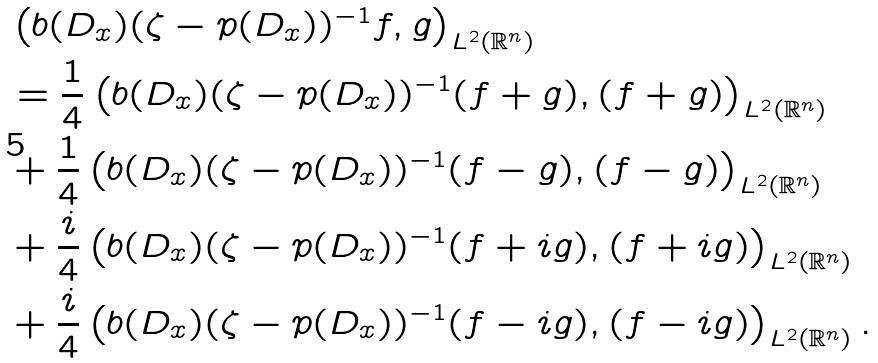<formula> <loc_0><loc_0><loc_500><loc_500>& \left ( b ( D _ { x } ) ( \zeta - p ( D _ { x } ) ) ^ { - 1 } f , g \right ) _ { L ^ { 2 } ( \mathbb { R } ^ { n } ) } \\ & = \frac { 1 } { 4 } \left ( b ( D _ { x } ) ( \zeta - p ( D _ { x } ) ) ^ { - 1 } ( f + g ) , ( f + g ) \right ) _ { L ^ { 2 } ( \mathbb { R } ^ { n } ) } \\ & + \frac { 1 } { 4 } \left ( b ( D _ { x } ) ( \zeta - p ( D _ { x } ) ) ^ { - 1 } ( f - g ) , ( f - g ) \right ) _ { L ^ { 2 } ( \mathbb { R } ^ { n } ) } \\ & + \frac { i } { 4 } \left ( b ( D _ { x } ) ( \zeta - p ( D _ { x } ) ) ^ { - 1 } ( f + i g ) , ( f + i g ) \right ) _ { L ^ { 2 } ( \mathbb { R } ^ { n } ) } \\ & + \frac { i } { 4 } \left ( b ( D _ { x } ) ( \zeta - p ( D _ { x } ) ) ^ { - 1 } ( f - i g ) , ( f - i g ) \right ) _ { L ^ { 2 } ( \mathbb { R } ^ { n } ) } .</formula> 